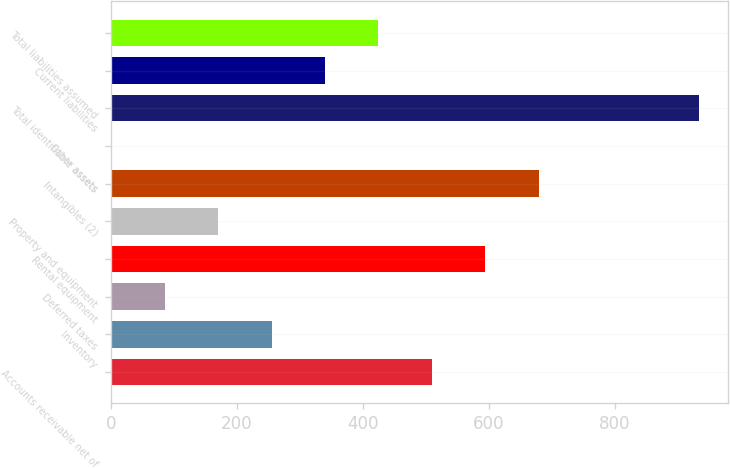Convert chart to OTSL. <chart><loc_0><loc_0><loc_500><loc_500><bar_chart><fcel>Accounts receivable net of<fcel>Inventory<fcel>Deferred taxes<fcel>Rental equipment<fcel>Property and equipment<fcel>Intangibles (2)<fcel>Other assets<fcel>Total identifiable assets<fcel>Current liabilities<fcel>Total liabilities assumed<nl><fcel>509.8<fcel>255.4<fcel>85.8<fcel>594.6<fcel>170.6<fcel>679.4<fcel>1<fcel>933.8<fcel>340.2<fcel>425<nl></chart> 